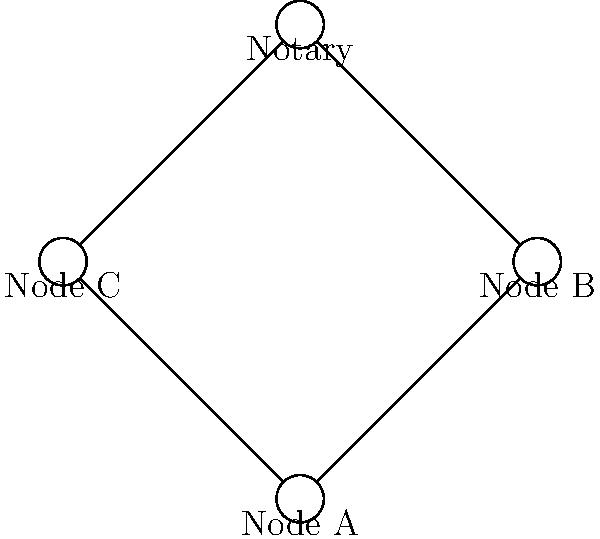In the given Corda network diagram, how many direct connections does the Notary have with other nodes? To answer this question, we need to analyze the structure of the Corda network shown in the diagram. Let's break it down step-by-step:

1. Identify the Notary: The Notary is located at the top of the diagram.

2. Identify the other nodes: There are three other nodes in the network - Node A, Node B, and Node C.

3. Examine the connections:
   - Node A is connected to both Node B and Node C.
   - Node B is connected to the Notary.
   - Node C is connected to the Notary.

4. Count the direct connections to the Notary:
   - There is a direct connection from Node B to the Notary.
   - There is a direct connection from Node C to the Notary.

5. Sum up the direct connections:
   The Notary has 2 direct connections with other nodes in the network.

It's important to note that in a Corda network, not all nodes need to be directly connected to the Notary. Nodes can communicate with the Notary when needed, typically for transaction validation and uniqueness checking.
Answer: 2 